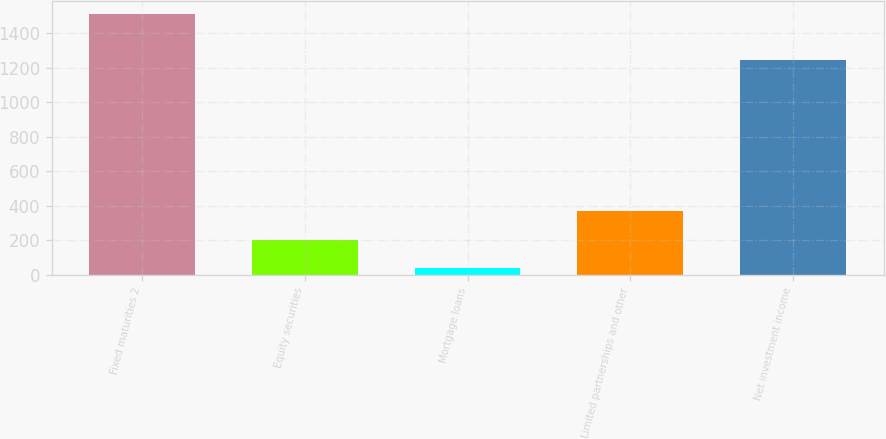Convert chart. <chart><loc_0><loc_0><loc_500><loc_500><bar_chart><fcel>Fixed maturities 2<fcel>Equity securities<fcel>Mortgage loans<fcel>Limited partnerships and other<fcel>Net investment income<nl><fcel>1511<fcel>202.9<fcel>38<fcel>367.8<fcel>1246<nl></chart> 